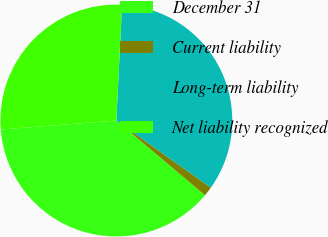Convert chart to OTSL. <chart><loc_0><loc_0><loc_500><loc_500><pie_chart><fcel>December 31<fcel>Current liability<fcel>Long-term liability<fcel>Net liability recognized<nl><fcel>37.61%<fcel>1.32%<fcel>34.04%<fcel>27.02%<nl></chart> 